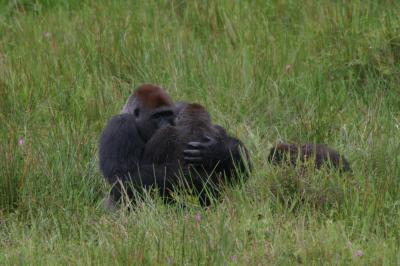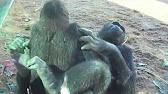The first image is the image on the left, the second image is the image on the right. Assess this claim about the two images: "At least one primate is looking directly forward.". Correct or not? Answer yes or no. No. The first image is the image on the left, the second image is the image on the right. Considering the images on both sides, is "One gorilla is scratching its own chin." valid? Answer yes or no. No. 